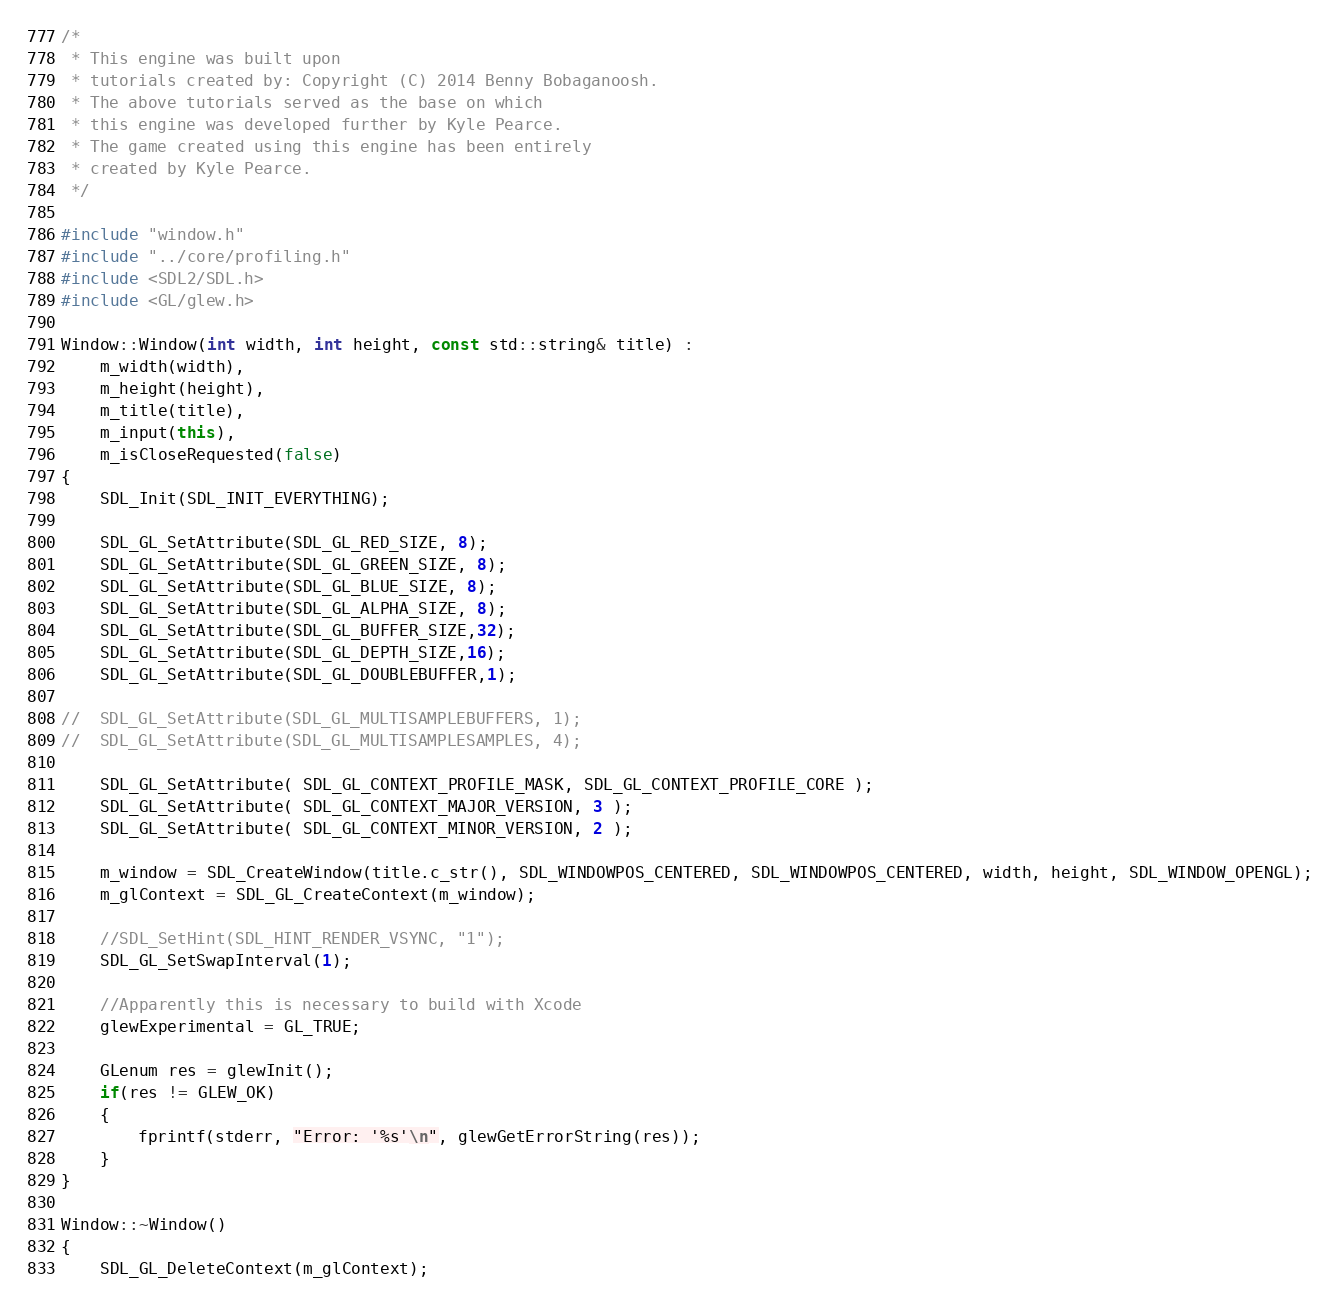Convert code to text. <code><loc_0><loc_0><loc_500><loc_500><_C++_>/*
 * This engine was built upon
 * tutorials created by: Copyright (C) 2014 Benny Bobaganoosh.
 * The above tutorials served as the base on which
 * this engine was developed further by Kyle Pearce.
 * The game created using this engine has been entirely
 * created by Kyle Pearce.
 */

#include "window.h"
#include "../core/profiling.h"
#include <SDL2/SDL.h>
#include <GL/glew.h>

Window::Window(int width, int height, const std::string& title) :
	m_width(width),
	m_height(height),
	m_title(title),
	m_input(this),
	m_isCloseRequested(false)
{
	SDL_Init(SDL_INIT_EVERYTHING);

	SDL_GL_SetAttribute(SDL_GL_RED_SIZE, 8);
	SDL_GL_SetAttribute(SDL_GL_GREEN_SIZE, 8);
	SDL_GL_SetAttribute(SDL_GL_BLUE_SIZE, 8);
	SDL_GL_SetAttribute(SDL_GL_ALPHA_SIZE, 8);
	SDL_GL_SetAttribute(SDL_GL_BUFFER_SIZE,32);
	SDL_GL_SetAttribute(SDL_GL_DEPTH_SIZE,16);
	SDL_GL_SetAttribute(SDL_GL_DOUBLEBUFFER,1);
	
//	SDL_GL_SetAttribute(SDL_GL_MULTISAMPLEBUFFERS, 1);
//	SDL_GL_SetAttribute(SDL_GL_MULTISAMPLESAMPLES, 4);

	SDL_GL_SetAttribute( SDL_GL_CONTEXT_PROFILE_MASK, SDL_GL_CONTEXT_PROFILE_CORE );
	SDL_GL_SetAttribute( SDL_GL_CONTEXT_MAJOR_VERSION, 3 );
	SDL_GL_SetAttribute( SDL_GL_CONTEXT_MINOR_VERSION, 2 );
	
	m_window = SDL_CreateWindow(title.c_str(), SDL_WINDOWPOS_CENTERED, SDL_WINDOWPOS_CENTERED, width, height, SDL_WINDOW_OPENGL);
	m_glContext = SDL_GL_CreateContext(m_window);

	//SDL_SetHint(SDL_HINT_RENDER_VSYNC, "1");
	SDL_GL_SetSwapInterval(1);

	//Apparently this is necessary to build with Xcode
	glewExperimental = GL_TRUE;
	
	GLenum res = glewInit();
	if(res != GLEW_OK)
	{
		fprintf(stderr, "Error: '%s'\n", glewGetErrorString(res));
	}
}

Window::~Window()
{
	SDL_GL_DeleteContext(m_glContext);</code> 